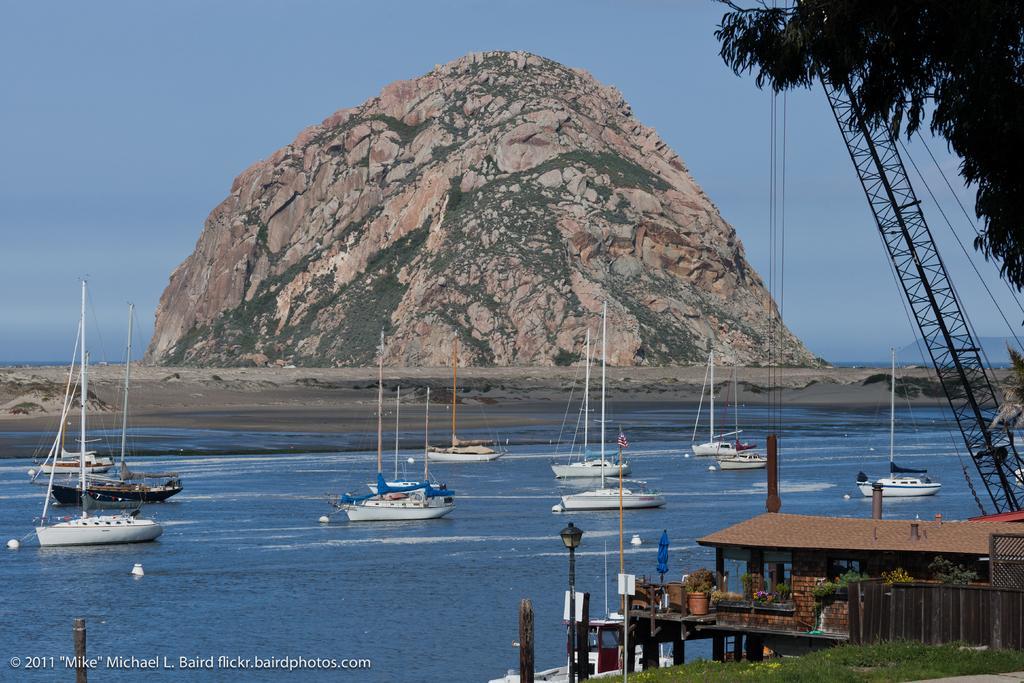Could you give a brief overview of what you see in this image? In the bottom right corner of the image there is grass on the ground. And also there is a wooden fencing. Behind the fencing there is a house with roofs, walls and windows. And also there are plants and poles with sign boards and lamps. Behind the house there is a crane with ropes. In the top right corner of the image there is a tree. In the image there is water. On the water there are boats with poles and ropes. In the background there is a hill and also there is sky. In the bottom left corner of the image there is something written on it. 